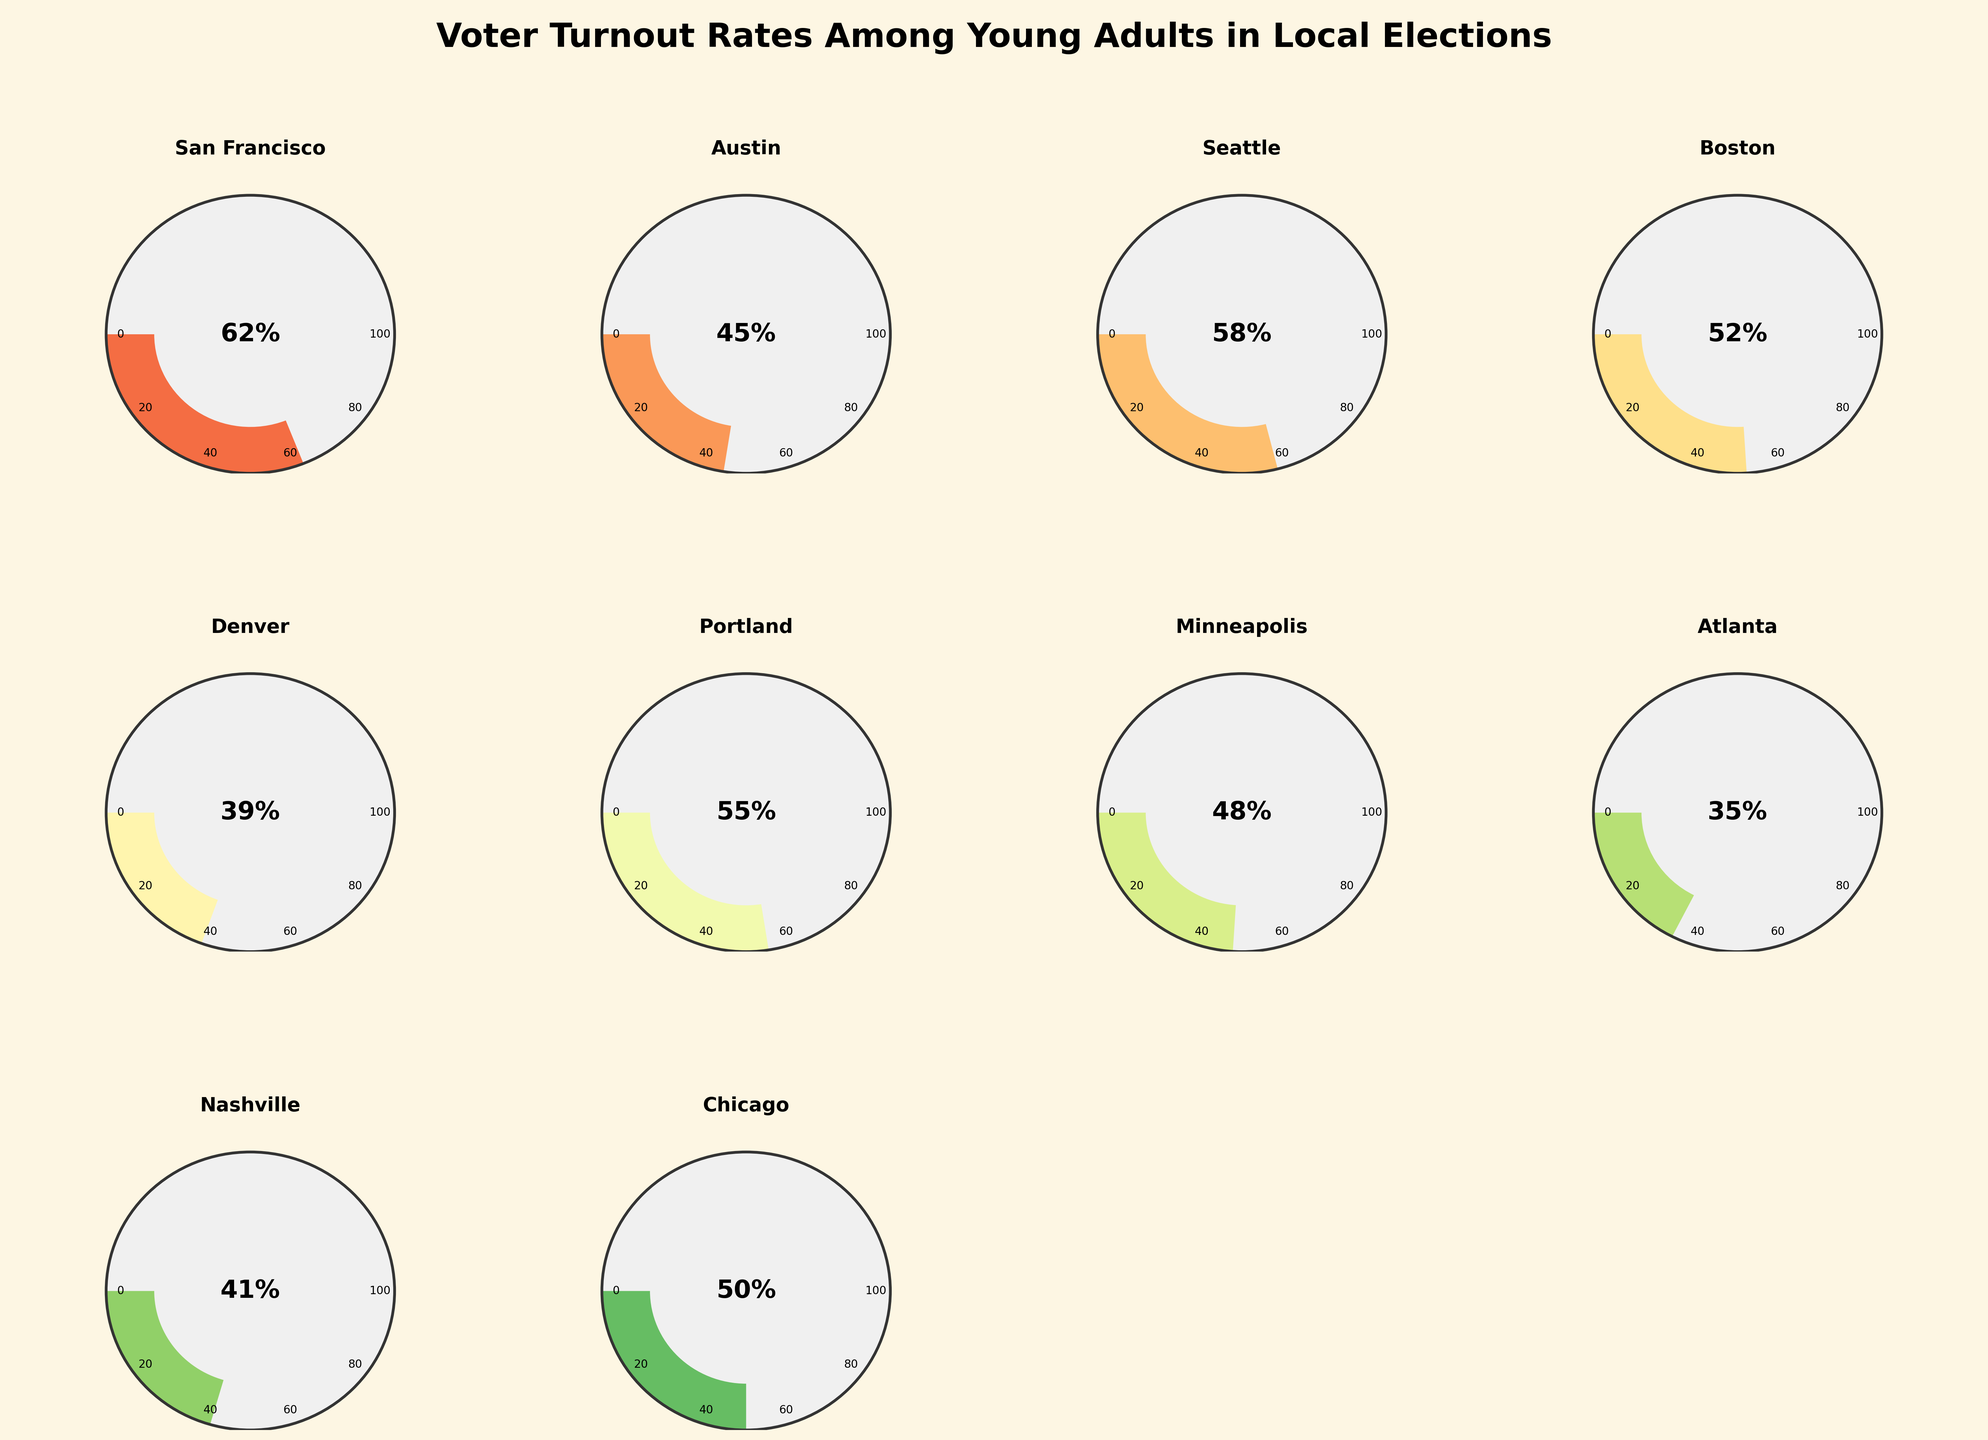How is the voter turnout rate among young adults represented in the figure? The figure uses gauge charts for each city to represent voter turnout rates among young adults. Each gauge is a semi-circle with a colored wedge to indicate the percentage of voter turnout. The gauge charts are arranged in a grid format with the city names and corresponding turnout percentages.
Answer: By gauge charts What is the title of the figure? The title is located at the top center of the figure. It reads "Voter Turnout Rates Among Young Adults in Local Elections," which clearly indicates the subject of the chart.
Answer: "Voter Turnout Rates Among Young Adults in Local Elections" Which city has the highest voter turnout rate among young adults? To determine the highest voter turnout rate, we need to look at all the gauges and identify the one with the highest percentage. San Francisco has the highest turnout rate at 62%.
Answer: San Francisco Which city has the lowest voter turnout rate among young adults? We need to find the gauge with the smallest wedge, which corresponds to Atlanta at 35%.
Answer: Atlanta How many cities have voter turnout rates above 50%? We must count all gauges with percentages greater than 50%. Those cities are San Francisco, Seattle, Portland.
Answer: 3 What is the average voter turnout rate among young adults across all the cities? The average voter turnout is calculated by summing all turnout percentages and dividing by the number of cities. The total is 445%, divided by 10 makes the average turnout 44.5%.
Answer: 44.5% What is the combined voter turnout rate of Austin and Chicago? Adding Austin's 45% and Chicago's 50% voter turnout, we get 45 + 50 = 95%.
Answer: 95% Is the voter turnout rate in Minneapolis higher or lower than in Boston? By comparing the wedges and percentages in their respective gauges, we see that Minneapolis has 48%, which is lower than Boston's 52%.
Answer: Lower How do the voter turnout rates of Denver and Nashville compare? Denver has a voter turnout rate of 39%, and Nashville has 41%. We need to compare these two values directly.
Answer: Nashville is higher Which two cities have the closest voter turnout rates among young adults? We need to identify pairs of cities with similar turnout rates. Minneapolis and Boston have quite close rates at 48% and 52%, respectively.
Answer: Minneapolis and Boston 